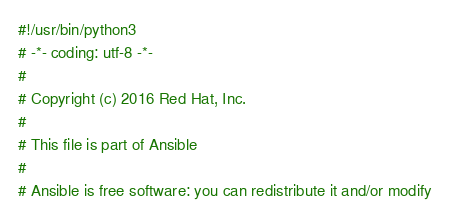<code> <loc_0><loc_0><loc_500><loc_500><_Python_>#!/usr/bin/python3
# -*- coding: utf-8 -*-
#
# Copyright (c) 2016 Red Hat, Inc.
#
# This file is part of Ansible
#
# Ansible is free software: you can redistribute it and/or modify</code> 